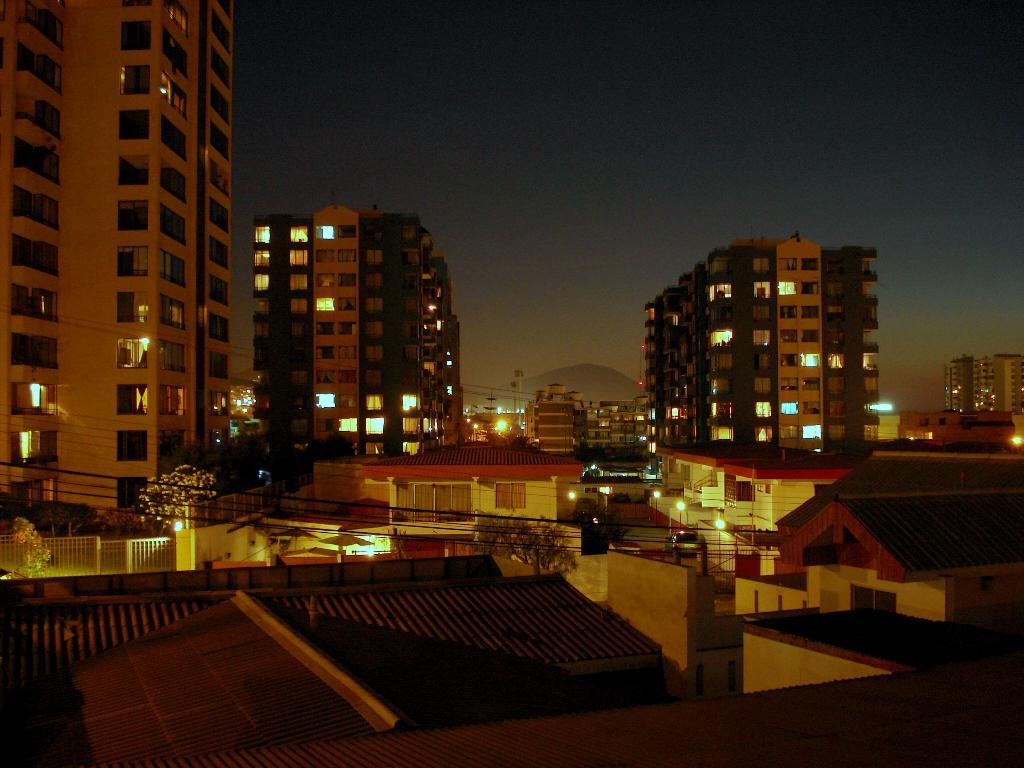What type of structures can be seen in the image? There are buildings in the image. What natural elements are present in the image? There are trees in the image. What artificial light sources are visible in the image? There are lights in the image. What geographical feature can be seen in the background of the image? There is a mountain in the background of the image. What is the condition of the sky in the background of the image? The sky is clear in the background of the image. What type of boundary can be seen in the image? There is no boundary present in the image. What things are depicted on the base of the mountain in the image? There is no base of a mountain present in the image, nor are there any things depicted on it. 